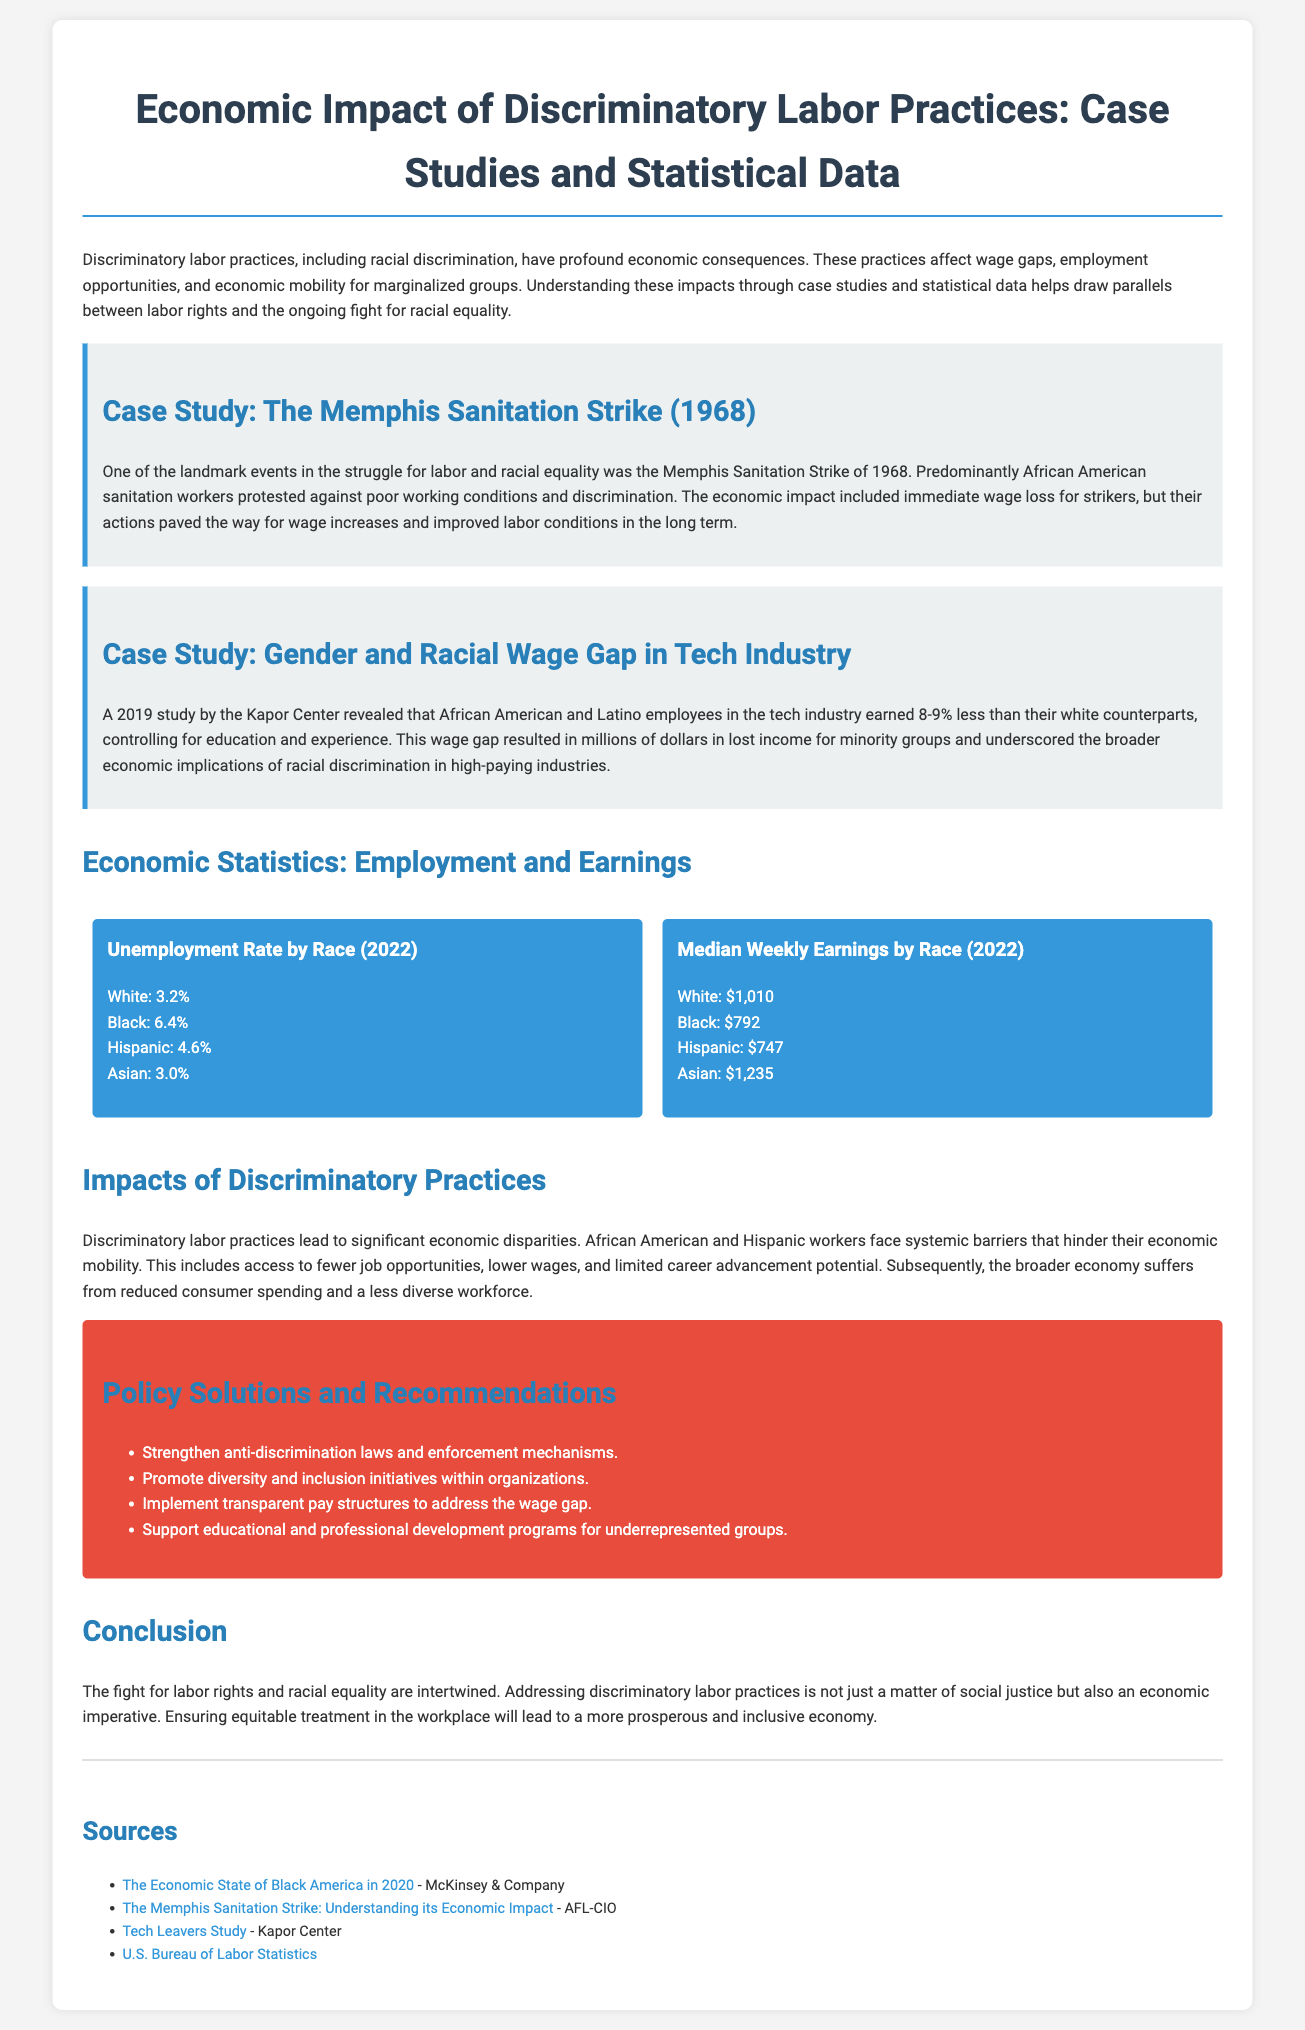What was the year of the Memphis Sanitation Strike? The document states that the Memphis Sanitation Strike occurred in 1968.
Answer: 1968 What is the unemployment rate for Black individuals in 2022? According to the statistics presented, the unemployment rate for Black individuals is 6.4%.
Answer: 6.4% What percentage less did African American employees in the tech industry earn compared to their white counterparts? The document indicates that African American employees earned 8-9% less than white counterparts.
Answer: 8-9% What are the median weekly earnings for Hispanic individuals in 2022? The document shows that the median weekly earnings for Hispanic individuals is $747.
Answer: $747 What significant barriers do African American and Hispanic workers face? The document mentions systemic barriers that hinder economic mobility for these groups.
Answer: Systemic barriers What is one recommendation listed for policy solutions? The document provides various recommendations, one being to strengthen anti-discrimination laws.
Answer: Strengthen anti-discrimination laws What was the economic impact of the Memphis Sanitation Strike? The strike initially led to wage loss for strikers but eventually resulted in wage increases and improved labor conditions.
Answer: Wage increases and improved labor conditions What does the document imply about the relationship between labor rights and racial equality? The conclusion emphasizes that addressing discriminatory practices is essential for social justice and economic prosperity.
Answer: Intertwined How does the document describe the broader economy's response to discriminatory labor practices? It notes that the economy suffers from reduced consumer spending and a less diverse workforce.
Answer: Reduced consumer spending and less diverse workforce 